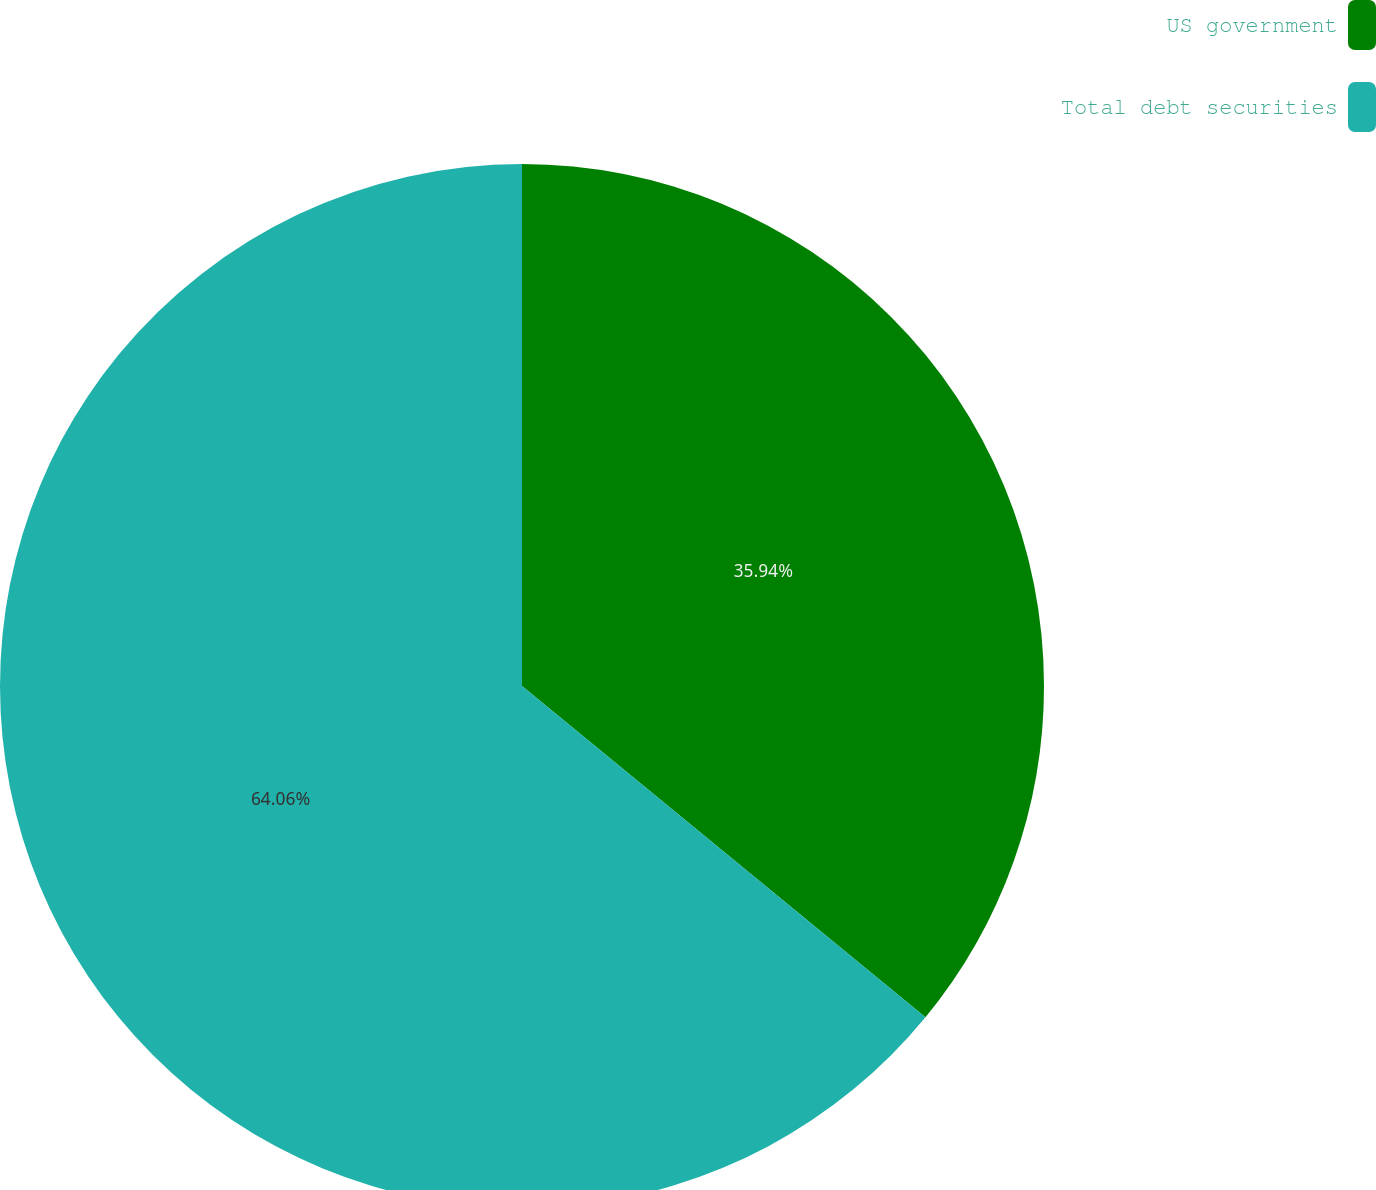Convert chart to OTSL. <chart><loc_0><loc_0><loc_500><loc_500><pie_chart><fcel>US government<fcel>Total debt securities<nl><fcel>35.94%<fcel>64.06%<nl></chart> 